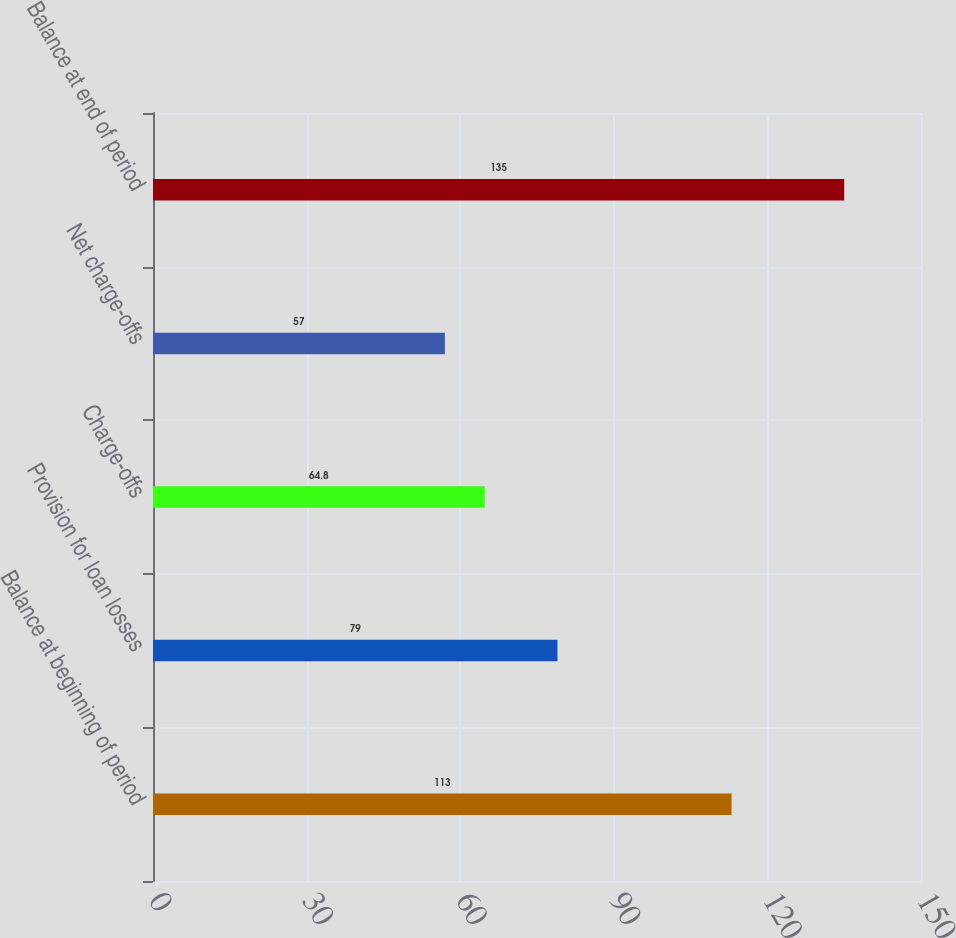Convert chart to OTSL. <chart><loc_0><loc_0><loc_500><loc_500><bar_chart><fcel>Balance at beginning of period<fcel>Provision for loan losses<fcel>Charge-offs<fcel>Net charge-offs<fcel>Balance at end of period<nl><fcel>113<fcel>79<fcel>64.8<fcel>57<fcel>135<nl></chart> 